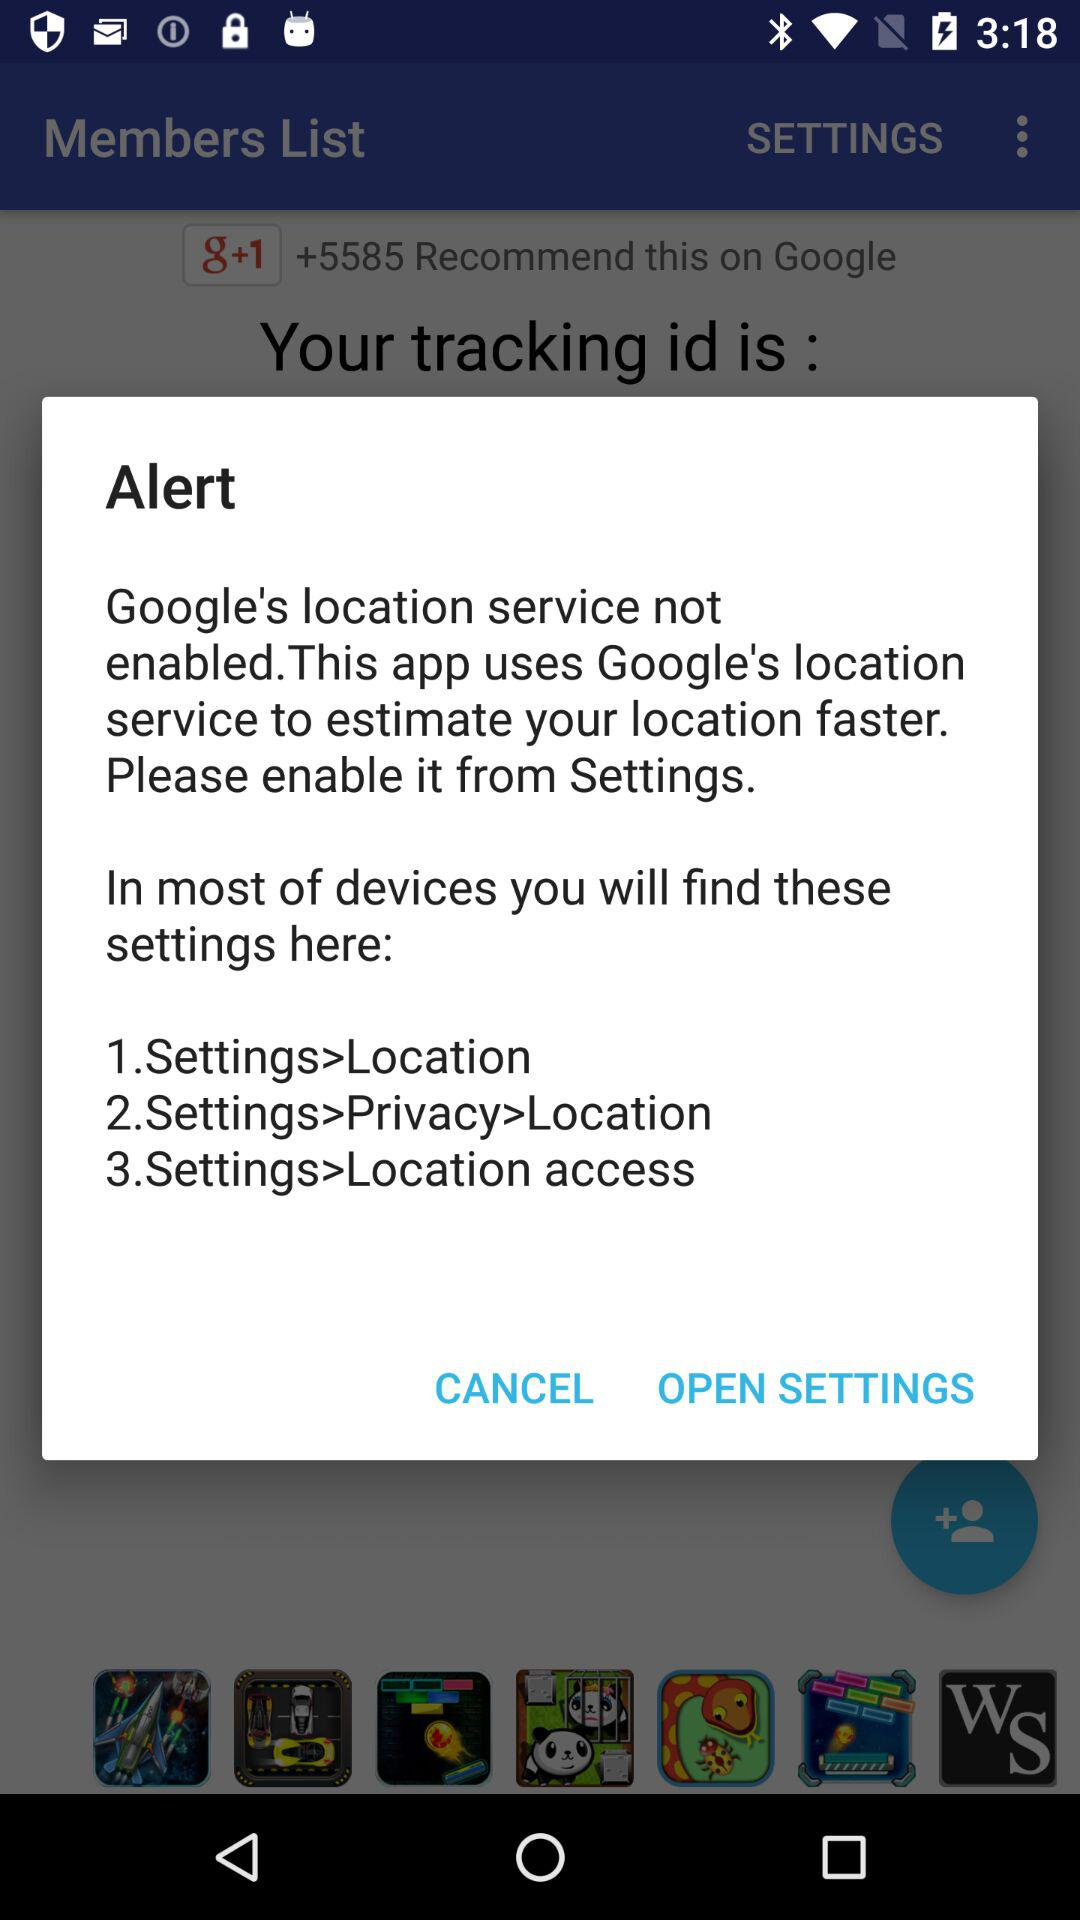How many steps are there in the instructions to enable Google's location service?
Answer the question using a single word or phrase. 3 